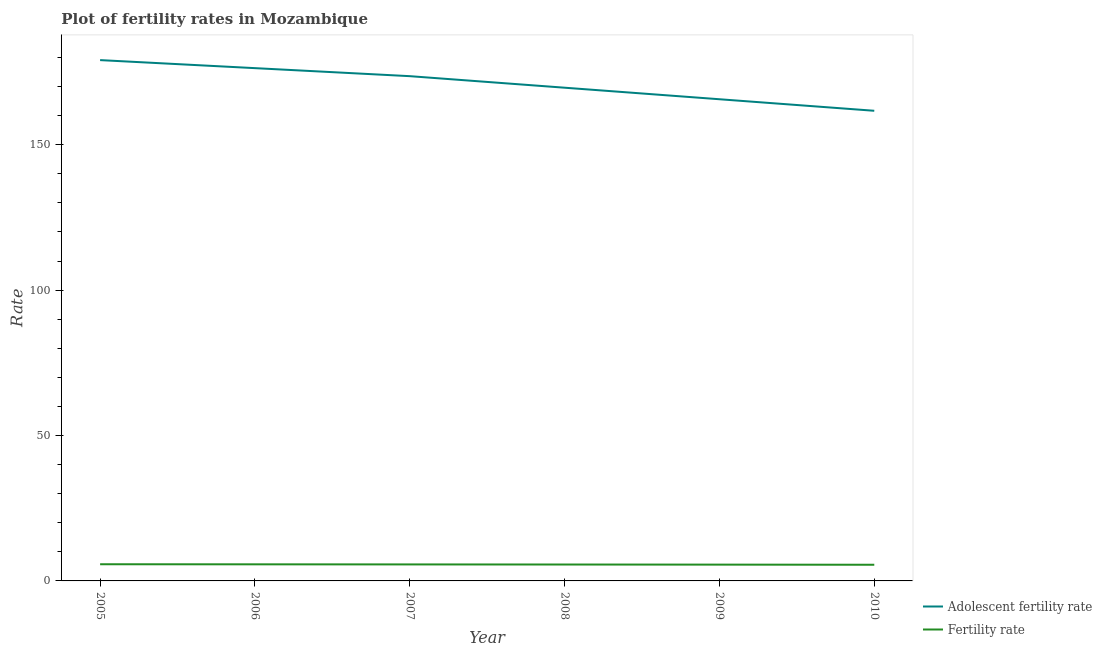Does the line corresponding to fertility rate intersect with the line corresponding to adolescent fertility rate?
Your answer should be compact. No. Is the number of lines equal to the number of legend labels?
Your answer should be very brief. Yes. What is the fertility rate in 2007?
Your answer should be very brief. 5.67. Across all years, what is the maximum fertility rate?
Ensure brevity in your answer.  5.74. Across all years, what is the minimum fertility rate?
Your response must be concise. 5.56. In which year was the fertility rate maximum?
Offer a terse response. 2005. What is the total adolescent fertility rate in the graph?
Ensure brevity in your answer.  1026. What is the difference between the fertility rate in 2005 and that in 2010?
Your answer should be compact. 0.17. What is the difference between the fertility rate in 2007 and the adolescent fertility rate in 2008?
Your response must be concise. -163.95. What is the average adolescent fertility rate per year?
Your response must be concise. 171. In the year 2005, what is the difference between the adolescent fertility rate and fertility rate?
Offer a very short reply. 173.38. What is the ratio of the adolescent fertility rate in 2007 to that in 2008?
Keep it short and to the point. 1.02. Is the adolescent fertility rate in 2007 less than that in 2008?
Provide a succinct answer. No. Is the difference between the fertility rate in 2009 and 2010 greater than the difference between the adolescent fertility rate in 2009 and 2010?
Provide a short and direct response. No. What is the difference between the highest and the second highest adolescent fertility rate?
Your answer should be very brief. 2.76. What is the difference between the highest and the lowest adolescent fertility rate?
Make the answer very short. 17.43. In how many years, is the adolescent fertility rate greater than the average adolescent fertility rate taken over all years?
Keep it short and to the point. 3. Is the adolescent fertility rate strictly greater than the fertility rate over the years?
Offer a terse response. Yes. Is the fertility rate strictly less than the adolescent fertility rate over the years?
Ensure brevity in your answer.  Yes. How many lines are there?
Make the answer very short. 2. Are the values on the major ticks of Y-axis written in scientific E-notation?
Provide a succinct answer. No. Does the graph contain grids?
Offer a terse response. No. How many legend labels are there?
Your response must be concise. 2. How are the legend labels stacked?
Give a very brief answer. Vertical. What is the title of the graph?
Give a very brief answer. Plot of fertility rates in Mozambique. Does "Tetanus" appear as one of the legend labels in the graph?
Keep it short and to the point. No. What is the label or title of the X-axis?
Give a very brief answer. Year. What is the label or title of the Y-axis?
Ensure brevity in your answer.  Rate. What is the Rate of Adolescent fertility rate in 2005?
Keep it short and to the point. 179.11. What is the Rate in Fertility rate in 2005?
Keep it short and to the point. 5.74. What is the Rate in Adolescent fertility rate in 2006?
Make the answer very short. 176.35. What is the Rate in Fertility rate in 2006?
Offer a terse response. 5.71. What is the Rate of Adolescent fertility rate in 2007?
Ensure brevity in your answer.  173.59. What is the Rate in Fertility rate in 2007?
Provide a succinct answer. 5.67. What is the Rate in Adolescent fertility rate in 2008?
Provide a succinct answer. 169.62. What is the Rate of Fertility rate in 2008?
Your answer should be compact. 5.64. What is the Rate of Adolescent fertility rate in 2009?
Offer a very short reply. 165.65. What is the Rate of Fertility rate in 2009?
Provide a succinct answer. 5.6. What is the Rate in Adolescent fertility rate in 2010?
Provide a succinct answer. 161.68. What is the Rate in Fertility rate in 2010?
Ensure brevity in your answer.  5.56. Across all years, what is the maximum Rate in Adolescent fertility rate?
Provide a succinct answer. 179.11. Across all years, what is the maximum Rate in Fertility rate?
Offer a very short reply. 5.74. Across all years, what is the minimum Rate in Adolescent fertility rate?
Provide a short and direct response. 161.68. Across all years, what is the minimum Rate of Fertility rate?
Your response must be concise. 5.56. What is the total Rate of Adolescent fertility rate in the graph?
Make the answer very short. 1026. What is the total Rate in Fertility rate in the graph?
Ensure brevity in your answer.  33.92. What is the difference between the Rate in Adolescent fertility rate in 2005 and that in 2006?
Provide a succinct answer. 2.76. What is the difference between the Rate in Fertility rate in 2005 and that in 2006?
Provide a short and direct response. 0.03. What is the difference between the Rate in Adolescent fertility rate in 2005 and that in 2007?
Your response must be concise. 5.52. What is the difference between the Rate in Fertility rate in 2005 and that in 2007?
Make the answer very short. 0.06. What is the difference between the Rate of Adolescent fertility rate in 2005 and that in 2008?
Your response must be concise. 9.49. What is the difference between the Rate of Fertility rate in 2005 and that in 2008?
Ensure brevity in your answer.  0.1. What is the difference between the Rate in Adolescent fertility rate in 2005 and that in 2009?
Make the answer very short. 13.46. What is the difference between the Rate in Fertility rate in 2005 and that in 2009?
Your answer should be very brief. 0.13. What is the difference between the Rate in Adolescent fertility rate in 2005 and that in 2010?
Offer a very short reply. 17.43. What is the difference between the Rate in Fertility rate in 2005 and that in 2010?
Keep it short and to the point. 0.17. What is the difference between the Rate of Adolescent fertility rate in 2006 and that in 2007?
Your response must be concise. 2.76. What is the difference between the Rate in Fertility rate in 2006 and that in 2007?
Keep it short and to the point. 0.03. What is the difference between the Rate of Adolescent fertility rate in 2006 and that in 2008?
Give a very brief answer. 6.73. What is the difference between the Rate in Fertility rate in 2006 and that in 2008?
Your answer should be very brief. 0.07. What is the difference between the Rate of Adolescent fertility rate in 2006 and that in 2009?
Offer a terse response. 10.7. What is the difference between the Rate in Fertility rate in 2006 and that in 2009?
Make the answer very short. 0.1. What is the difference between the Rate in Adolescent fertility rate in 2006 and that in 2010?
Offer a very short reply. 14.67. What is the difference between the Rate in Fertility rate in 2006 and that in 2010?
Offer a terse response. 0.14. What is the difference between the Rate of Adolescent fertility rate in 2007 and that in 2008?
Keep it short and to the point. 3.97. What is the difference between the Rate of Fertility rate in 2007 and that in 2008?
Provide a succinct answer. 0.03. What is the difference between the Rate in Adolescent fertility rate in 2007 and that in 2009?
Your answer should be very brief. 7.94. What is the difference between the Rate in Fertility rate in 2007 and that in 2009?
Offer a terse response. 0.07. What is the difference between the Rate of Adolescent fertility rate in 2007 and that in 2010?
Offer a very short reply. 11.91. What is the difference between the Rate of Fertility rate in 2007 and that in 2010?
Provide a short and direct response. 0.11. What is the difference between the Rate in Adolescent fertility rate in 2008 and that in 2009?
Provide a succinct answer. 3.97. What is the difference between the Rate of Fertility rate in 2008 and that in 2009?
Offer a very short reply. 0.04. What is the difference between the Rate of Adolescent fertility rate in 2008 and that in 2010?
Your answer should be very brief. 7.94. What is the difference between the Rate of Fertility rate in 2008 and that in 2010?
Provide a succinct answer. 0.08. What is the difference between the Rate of Adolescent fertility rate in 2009 and that in 2010?
Make the answer very short. 3.97. What is the difference between the Rate of Fertility rate in 2009 and that in 2010?
Offer a terse response. 0.04. What is the difference between the Rate of Adolescent fertility rate in 2005 and the Rate of Fertility rate in 2006?
Your answer should be compact. 173.4. What is the difference between the Rate in Adolescent fertility rate in 2005 and the Rate in Fertility rate in 2007?
Provide a succinct answer. 173.44. What is the difference between the Rate of Adolescent fertility rate in 2005 and the Rate of Fertility rate in 2008?
Provide a short and direct response. 173.47. What is the difference between the Rate in Adolescent fertility rate in 2005 and the Rate in Fertility rate in 2009?
Your answer should be very brief. 173.51. What is the difference between the Rate in Adolescent fertility rate in 2005 and the Rate in Fertility rate in 2010?
Offer a very short reply. 173.55. What is the difference between the Rate in Adolescent fertility rate in 2006 and the Rate in Fertility rate in 2007?
Make the answer very short. 170.68. What is the difference between the Rate of Adolescent fertility rate in 2006 and the Rate of Fertility rate in 2008?
Give a very brief answer. 170.71. What is the difference between the Rate in Adolescent fertility rate in 2006 and the Rate in Fertility rate in 2009?
Provide a succinct answer. 170.75. What is the difference between the Rate of Adolescent fertility rate in 2006 and the Rate of Fertility rate in 2010?
Make the answer very short. 170.79. What is the difference between the Rate in Adolescent fertility rate in 2007 and the Rate in Fertility rate in 2008?
Offer a terse response. 167.95. What is the difference between the Rate of Adolescent fertility rate in 2007 and the Rate of Fertility rate in 2009?
Your response must be concise. 167.99. What is the difference between the Rate in Adolescent fertility rate in 2007 and the Rate in Fertility rate in 2010?
Your response must be concise. 168.03. What is the difference between the Rate in Adolescent fertility rate in 2008 and the Rate in Fertility rate in 2009?
Make the answer very short. 164.02. What is the difference between the Rate of Adolescent fertility rate in 2008 and the Rate of Fertility rate in 2010?
Provide a succinct answer. 164.06. What is the difference between the Rate of Adolescent fertility rate in 2009 and the Rate of Fertility rate in 2010?
Your response must be concise. 160.09. What is the average Rate in Adolescent fertility rate per year?
Your answer should be very brief. 171. What is the average Rate of Fertility rate per year?
Keep it short and to the point. 5.65. In the year 2005, what is the difference between the Rate in Adolescent fertility rate and Rate in Fertility rate?
Offer a terse response. 173.38. In the year 2006, what is the difference between the Rate of Adolescent fertility rate and Rate of Fertility rate?
Your answer should be compact. 170.64. In the year 2007, what is the difference between the Rate of Adolescent fertility rate and Rate of Fertility rate?
Your answer should be very brief. 167.91. In the year 2008, what is the difference between the Rate of Adolescent fertility rate and Rate of Fertility rate?
Provide a short and direct response. 163.98. In the year 2009, what is the difference between the Rate of Adolescent fertility rate and Rate of Fertility rate?
Your answer should be compact. 160.05. In the year 2010, what is the difference between the Rate in Adolescent fertility rate and Rate in Fertility rate?
Provide a short and direct response. 156.12. What is the ratio of the Rate of Adolescent fertility rate in 2005 to that in 2006?
Make the answer very short. 1.02. What is the ratio of the Rate in Fertility rate in 2005 to that in 2006?
Give a very brief answer. 1.01. What is the ratio of the Rate in Adolescent fertility rate in 2005 to that in 2007?
Keep it short and to the point. 1.03. What is the ratio of the Rate of Fertility rate in 2005 to that in 2007?
Provide a short and direct response. 1.01. What is the ratio of the Rate of Adolescent fertility rate in 2005 to that in 2008?
Offer a terse response. 1.06. What is the ratio of the Rate in Adolescent fertility rate in 2005 to that in 2009?
Keep it short and to the point. 1.08. What is the ratio of the Rate of Fertility rate in 2005 to that in 2009?
Offer a terse response. 1.02. What is the ratio of the Rate in Adolescent fertility rate in 2005 to that in 2010?
Offer a terse response. 1.11. What is the ratio of the Rate of Fertility rate in 2005 to that in 2010?
Your response must be concise. 1.03. What is the ratio of the Rate of Adolescent fertility rate in 2006 to that in 2007?
Offer a very short reply. 1.02. What is the ratio of the Rate in Adolescent fertility rate in 2006 to that in 2008?
Ensure brevity in your answer.  1.04. What is the ratio of the Rate of Fertility rate in 2006 to that in 2008?
Your answer should be very brief. 1.01. What is the ratio of the Rate in Adolescent fertility rate in 2006 to that in 2009?
Provide a succinct answer. 1.06. What is the ratio of the Rate in Fertility rate in 2006 to that in 2009?
Offer a terse response. 1.02. What is the ratio of the Rate in Adolescent fertility rate in 2006 to that in 2010?
Provide a short and direct response. 1.09. What is the ratio of the Rate in Fertility rate in 2006 to that in 2010?
Your response must be concise. 1.03. What is the ratio of the Rate in Adolescent fertility rate in 2007 to that in 2008?
Offer a terse response. 1.02. What is the ratio of the Rate in Fertility rate in 2007 to that in 2008?
Your response must be concise. 1.01. What is the ratio of the Rate in Adolescent fertility rate in 2007 to that in 2009?
Ensure brevity in your answer.  1.05. What is the ratio of the Rate in Fertility rate in 2007 to that in 2009?
Make the answer very short. 1.01. What is the ratio of the Rate of Adolescent fertility rate in 2007 to that in 2010?
Make the answer very short. 1.07. What is the ratio of the Rate of Fertility rate in 2007 to that in 2010?
Your response must be concise. 1.02. What is the ratio of the Rate in Fertility rate in 2008 to that in 2009?
Offer a very short reply. 1.01. What is the ratio of the Rate of Adolescent fertility rate in 2008 to that in 2010?
Offer a very short reply. 1.05. What is the ratio of the Rate of Fertility rate in 2008 to that in 2010?
Give a very brief answer. 1.01. What is the ratio of the Rate in Adolescent fertility rate in 2009 to that in 2010?
Provide a short and direct response. 1.02. What is the difference between the highest and the second highest Rate of Adolescent fertility rate?
Make the answer very short. 2.76. What is the difference between the highest and the second highest Rate in Fertility rate?
Provide a short and direct response. 0.03. What is the difference between the highest and the lowest Rate in Adolescent fertility rate?
Give a very brief answer. 17.43. What is the difference between the highest and the lowest Rate in Fertility rate?
Your response must be concise. 0.17. 